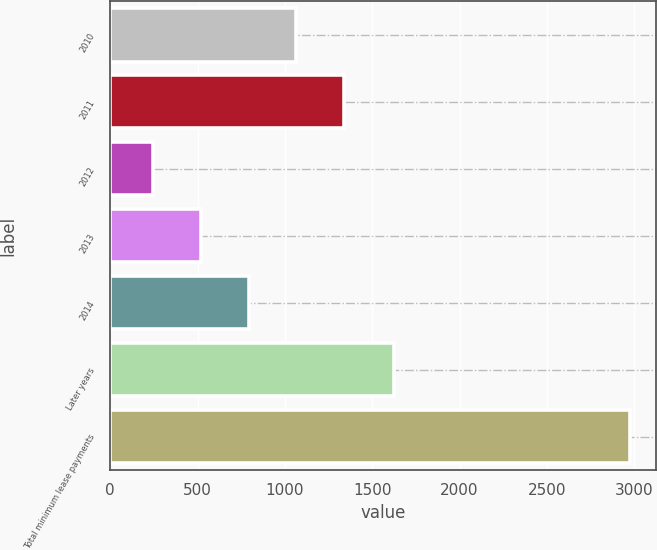<chart> <loc_0><loc_0><loc_500><loc_500><bar_chart><fcel>2010<fcel>2011<fcel>2012<fcel>2013<fcel>2014<fcel>Later years<fcel>Total minimum lease payments<nl><fcel>1065.4<fcel>1338.2<fcel>247<fcel>519.8<fcel>792.6<fcel>1623<fcel>2975<nl></chart> 